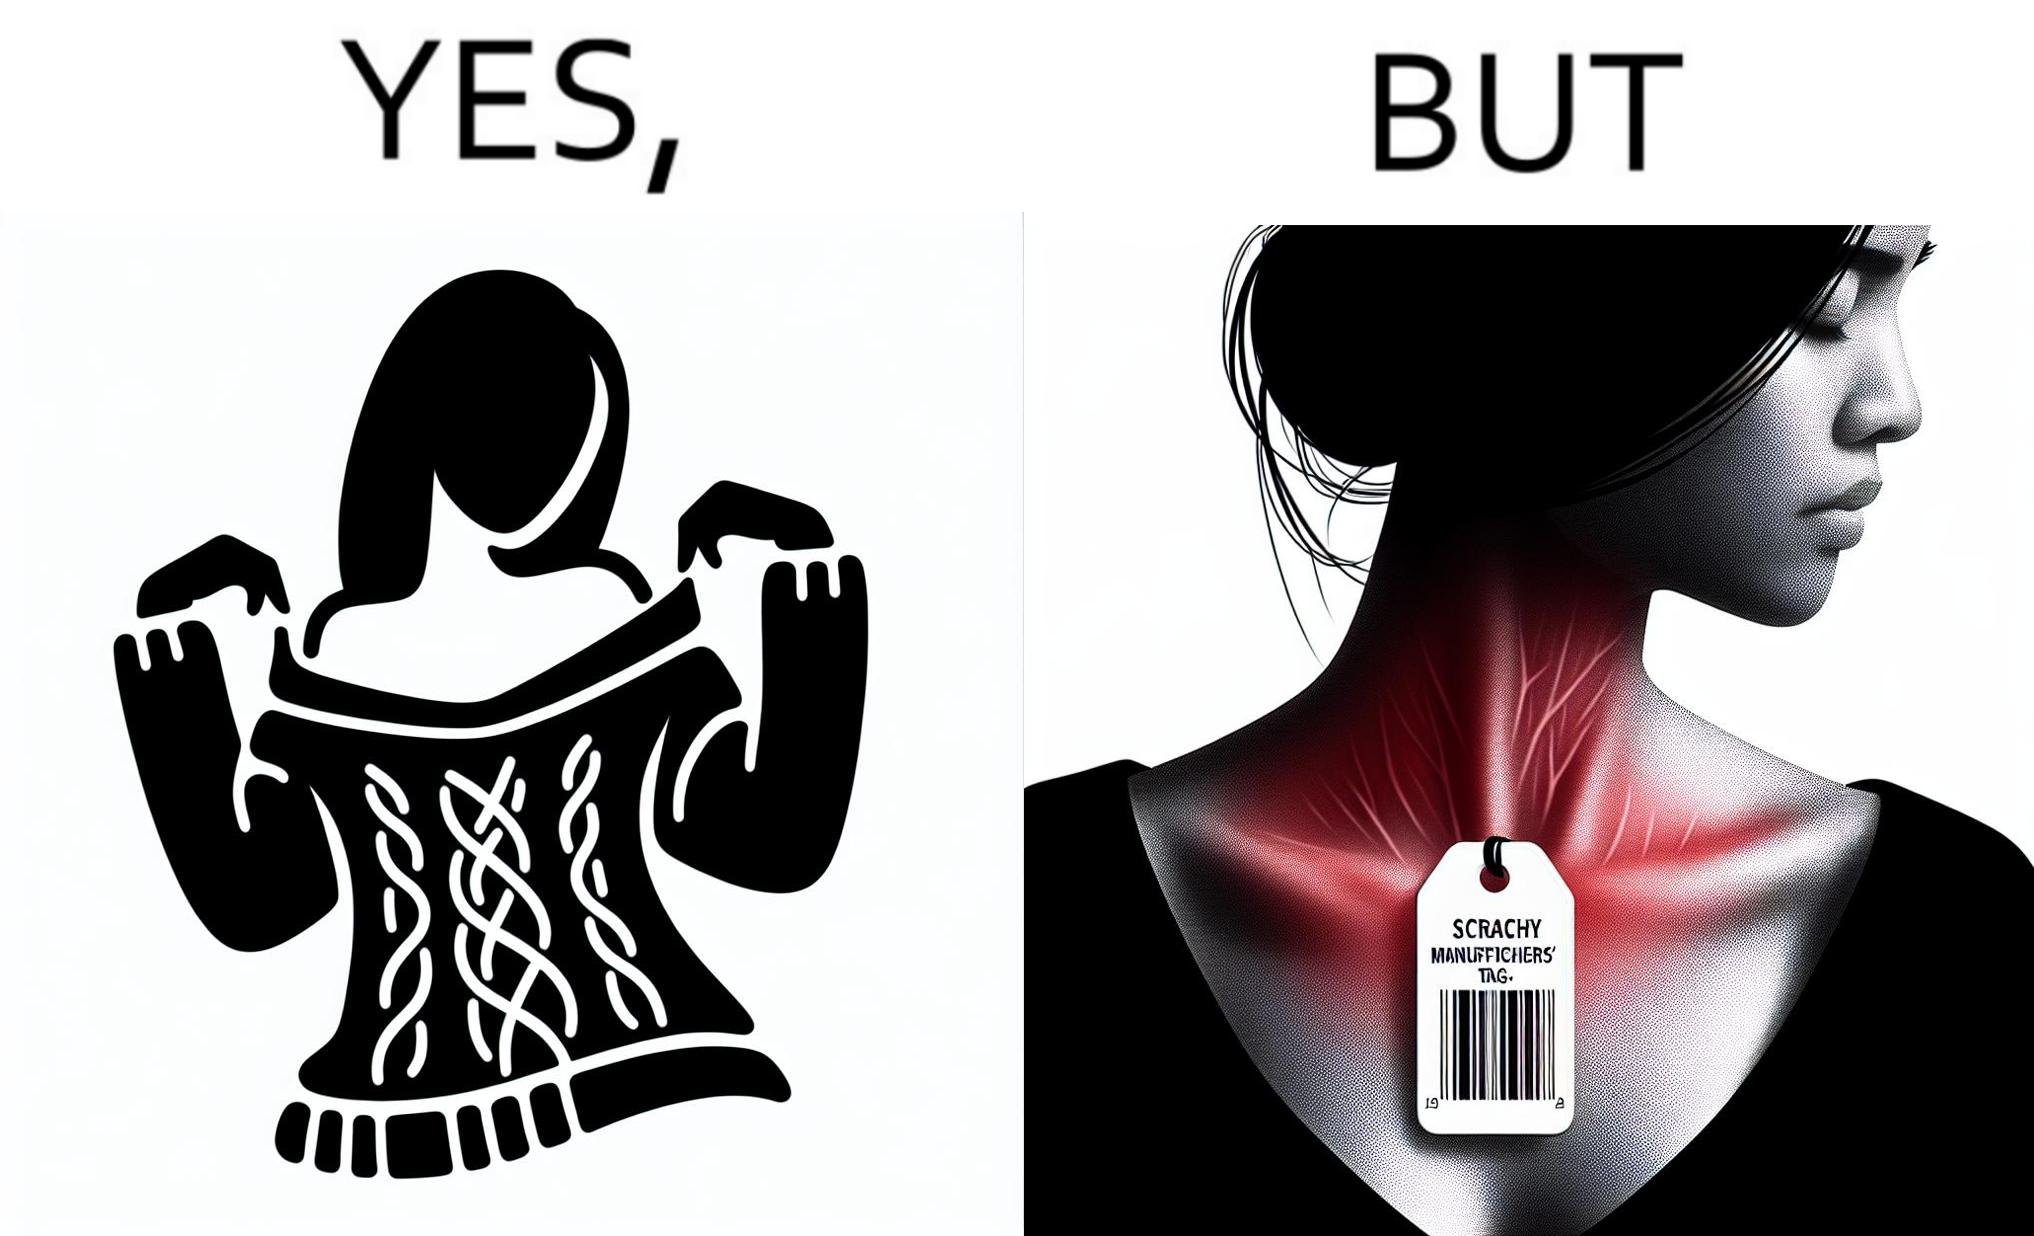Describe what you see in this image. The images are funny since it shows how even though sweaters and other clothings provide much comfort, a tiny manufacturers tag ends up causing the user a lot of discomfort due to constant scratching 